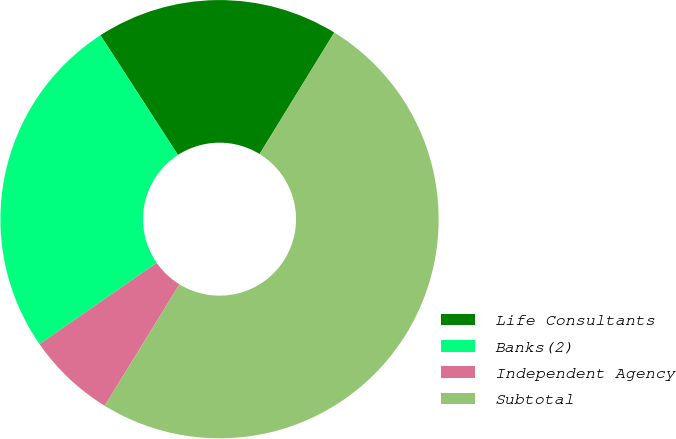<chart> <loc_0><loc_0><loc_500><loc_500><pie_chart><fcel>Life Consultants<fcel>Banks(2)<fcel>Independent Agency<fcel>Subtotal<nl><fcel>17.92%<fcel>25.51%<fcel>6.56%<fcel>50.0%<nl></chart> 